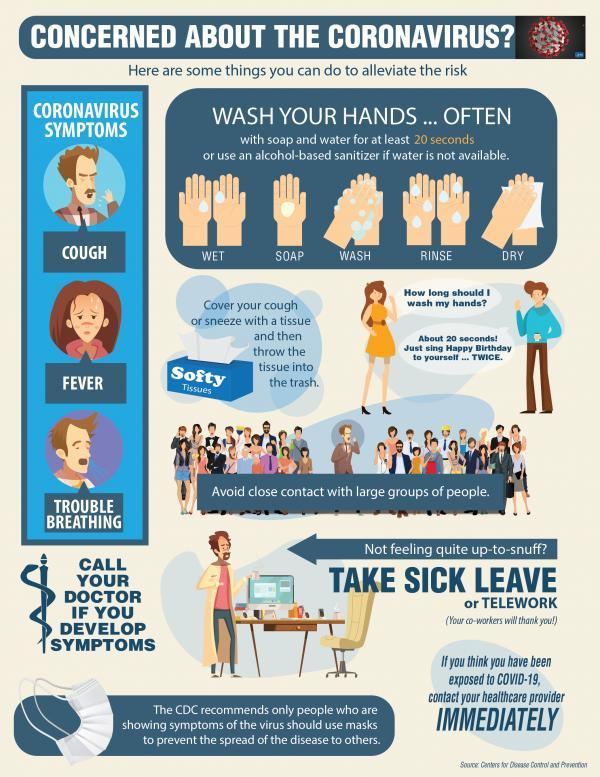How many symptoms of coronavirus are in this infographic?
Answer the question with a short phrase. 3 What is the name of the tissue referenced in this infographic? Softy tissue 